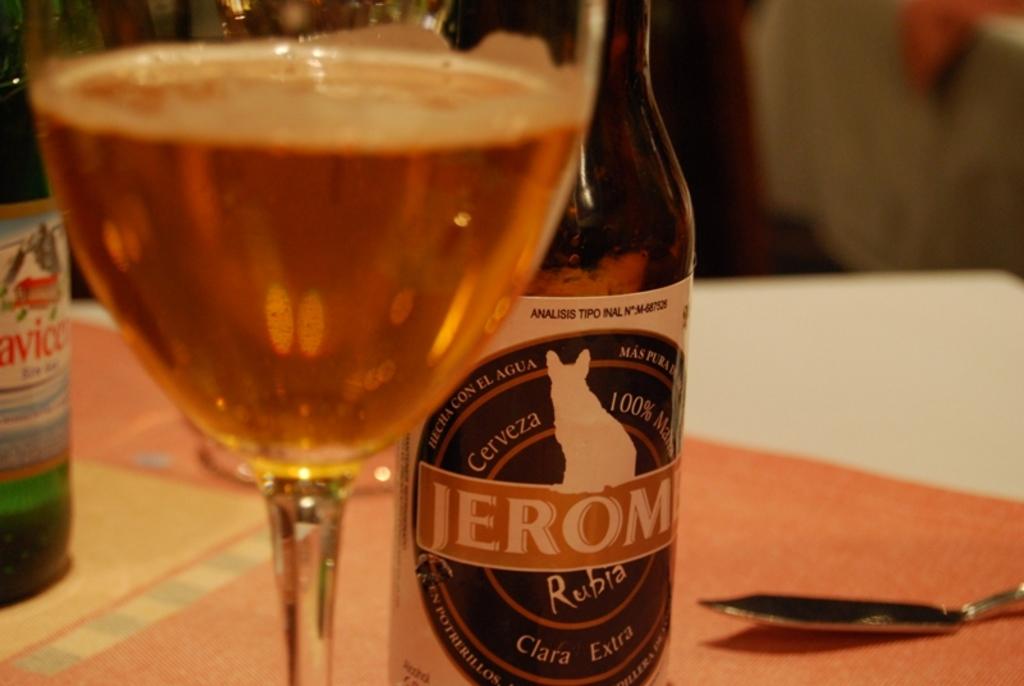What is the name of the beer?
Your answer should be compact. Jerom. 